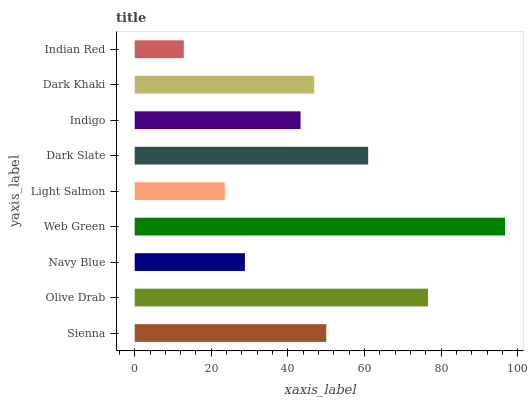Is Indian Red the minimum?
Answer yes or no. Yes. Is Web Green the maximum?
Answer yes or no. Yes. Is Olive Drab the minimum?
Answer yes or no. No. Is Olive Drab the maximum?
Answer yes or no. No. Is Olive Drab greater than Sienna?
Answer yes or no. Yes. Is Sienna less than Olive Drab?
Answer yes or no. Yes. Is Sienna greater than Olive Drab?
Answer yes or no. No. Is Olive Drab less than Sienna?
Answer yes or no. No. Is Dark Khaki the high median?
Answer yes or no. Yes. Is Dark Khaki the low median?
Answer yes or no. Yes. Is Indigo the high median?
Answer yes or no. No. Is Indian Red the low median?
Answer yes or no. No. 